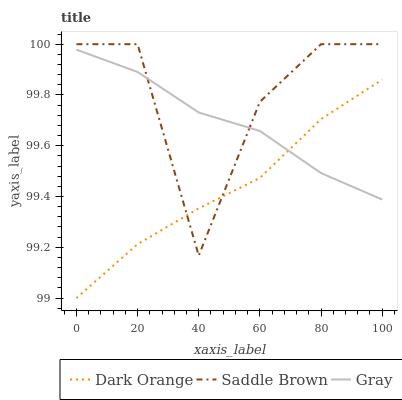Does Dark Orange have the minimum area under the curve?
Answer yes or no. Yes. Does Saddle Brown have the maximum area under the curve?
Answer yes or no. Yes. Does Gray have the minimum area under the curve?
Answer yes or no. No. Does Gray have the maximum area under the curve?
Answer yes or no. No. Is Dark Orange the smoothest?
Answer yes or no. Yes. Is Saddle Brown the roughest?
Answer yes or no. Yes. Is Gray the smoothest?
Answer yes or no. No. Is Gray the roughest?
Answer yes or no. No. Does Dark Orange have the lowest value?
Answer yes or no. Yes. Does Saddle Brown have the lowest value?
Answer yes or no. No. Does Saddle Brown have the highest value?
Answer yes or no. Yes. Does Gray have the highest value?
Answer yes or no. No. Does Gray intersect Dark Orange?
Answer yes or no. Yes. Is Gray less than Dark Orange?
Answer yes or no. No. Is Gray greater than Dark Orange?
Answer yes or no. No. 